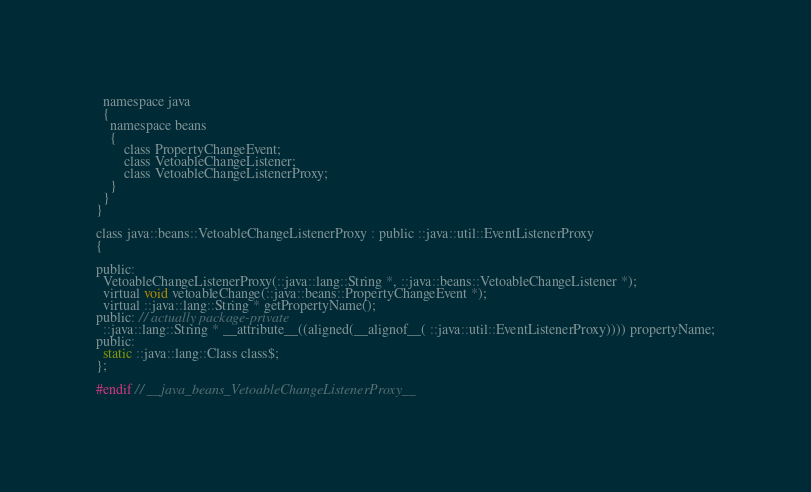Convert code to text. <code><loc_0><loc_0><loc_500><loc_500><_C_>  namespace java
  {
    namespace beans
    {
        class PropertyChangeEvent;
        class VetoableChangeListener;
        class VetoableChangeListenerProxy;
    }
  }
}

class java::beans::VetoableChangeListenerProxy : public ::java::util::EventListenerProxy
{

public:
  VetoableChangeListenerProxy(::java::lang::String *, ::java::beans::VetoableChangeListener *);
  virtual void vetoableChange(::java::beans::PropertyChangeEvent *);
  virtual ::java::lang::String * getPropertyName();
public: // actually package-private
  ::java::lang::String * __attribute__((aligned(__alignof__( ::java::util::EventListenerProxy)))) propertyName;
public:
  static ::java::lang::Class class$;
};

#endif // __java_beans_VetoableChangeListenerProxy__
</code> 